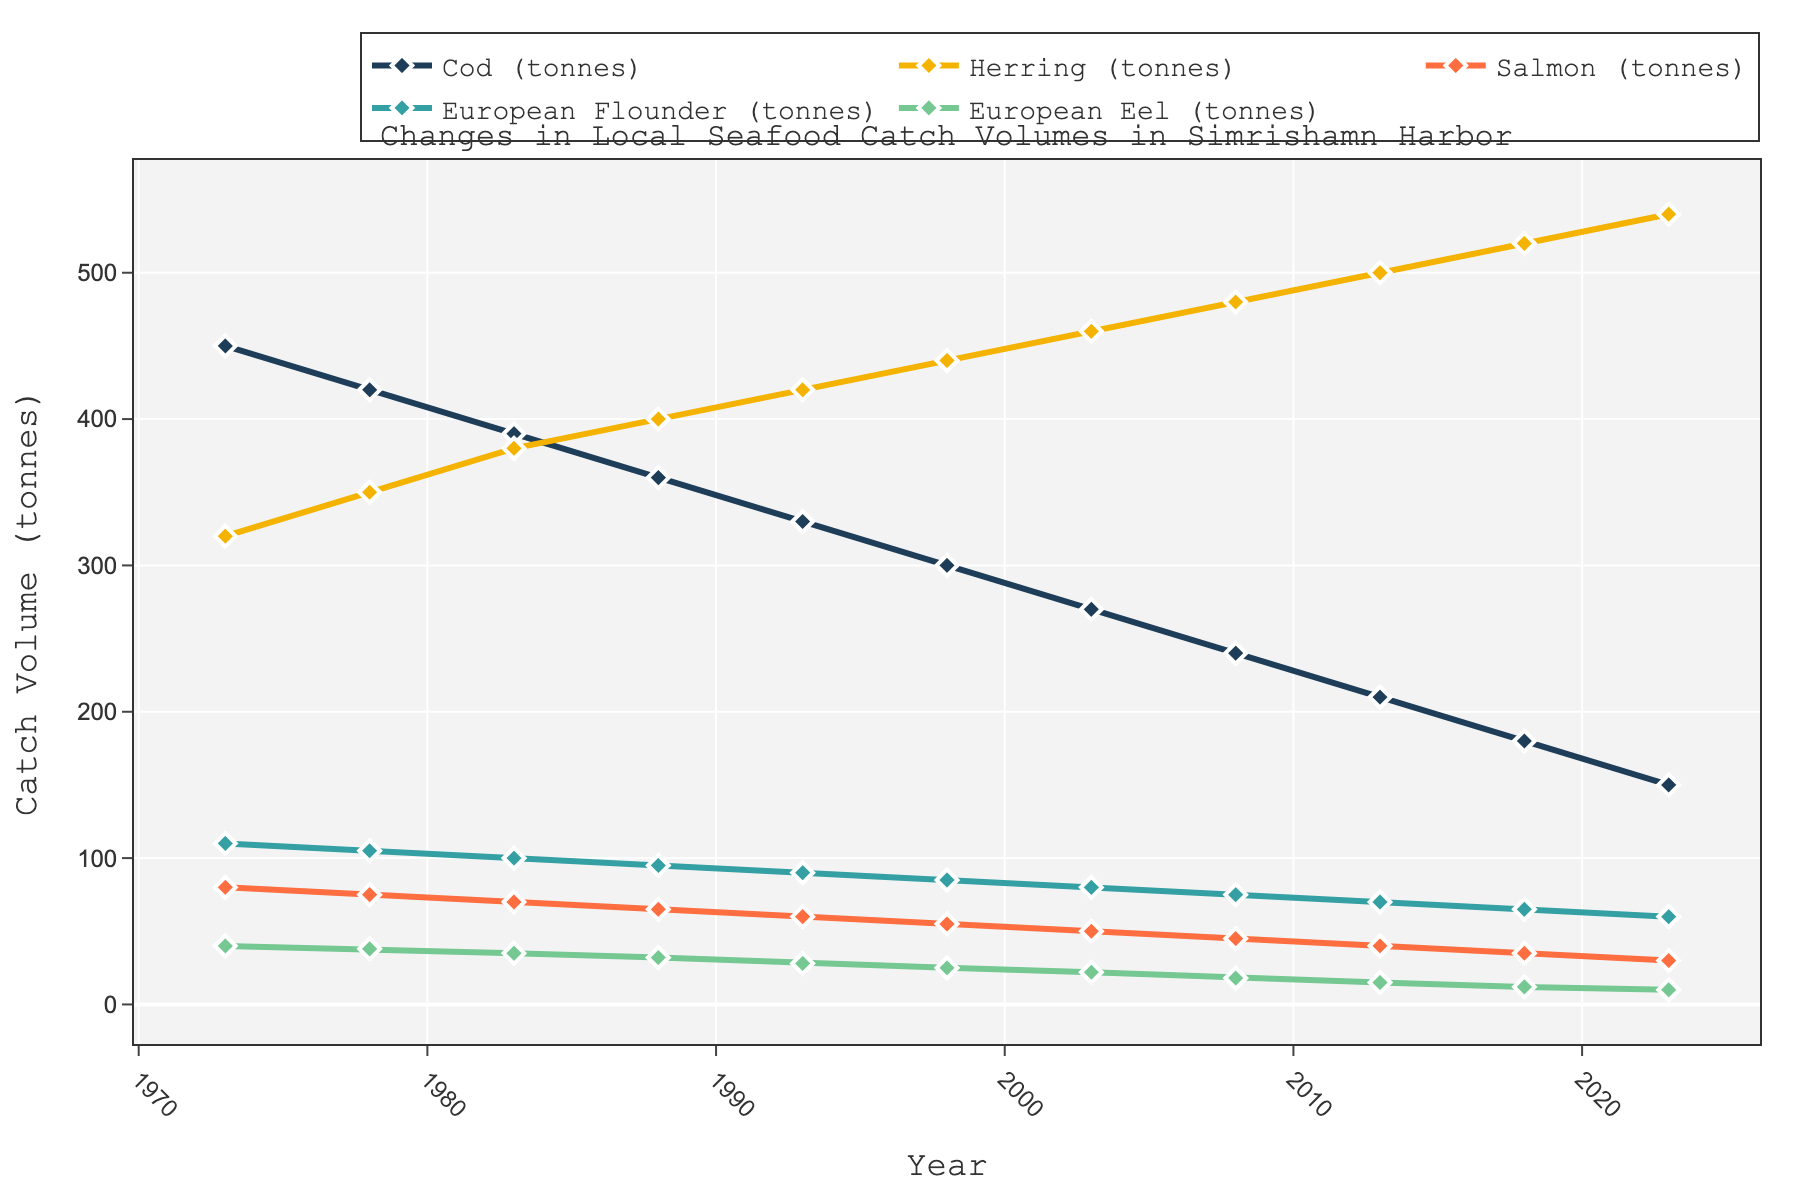What is the trend in Cod catch volume from 1973 to 2023? The Cod catch volume shows a decreasing trend over the years. By examining the plotted line for Cod, we see a consistent decline from 450 tonnes in 1973 to 150 tonnes in 2023, indicating a steady reduction in Cod catch.
Answer: Decreasing trend Which year had the highest volume of Herring catch? To determine this, we look at the plotted line for Herring and identify the peak point. We observe that the volume of Herring catch is highest in 2023 at 540 tonnes.
Answer: 2023 How does the volume of Salmon catch in 2013 compare to 1983? Check the plotted line for Salmon at both 1983 and 2013. In 1983, the catch is 70 tonnes, while in 2013, it is 40 tonnes. Hence, the Salmon catch volume decreased by 30 tonnes over this period.
Answer: Decreased by 30 tonnes What is the average catch volume of European Flounder over the 50 years? To find the average, sum up the catch volumes for European Flounder for all years and divide by the number of years. The volumes are 110, 105, 100, 95, 90, 85, 80, 75, 70, 65, and 60. Adding them results in 935 tonnes. Divide 935 by 11 (number of years) to get approximately 85 tonnes.
Answer: Approximately 85 tonnes Which seafood type showed the most stability in catch volumes over the 50 years? By observing the plotted lines for all seafood types, the line representing European Eel appears relatively flatter compared to others, indicating the least variation.
Answer: European Eel In which year did the catch volume for Cod and European Flounder both intersect or have the same value? No specific intersection point is evident by closely observing the graphs for Cod and European Flounder. The lines do not intersect at any point, indicating no year in which their volumes were equal.
Answer: None What is the difference in Salmon catch volumes between 1973 and 2023? By looking at the Salmon plot line and noting down both values, the volume in 1973 is 80 tonnes, and in 2023 it is 30 tonnes. Hence, the difference in catch volumes is 50 tonnes.
Answer: 50 tonnes Which fish type experienced the greatest decrease in catch volume from 1973 to 2023? By comparing the initial and final values for all fish types, Cod shows the highest decrease from 450 tonnes in 1973 to 150 tonnes in 2023, a reduction of 300 tonnes.
Answer: Cod 